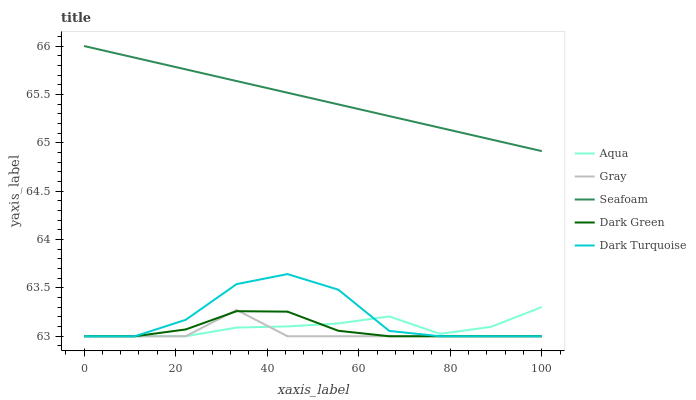Does Gray have the minimum area under the curve?
Answer yes or no. Yes. Does Seafoam have the maximum area under the curve?
Answer yes or no. Yes. Does Aqua have the minimum area under the curve?
Answer yes or no. No. Does Aqua have the maximum area under the curve?
Answer yes or no. No. Is Seafoam the smoothest?
Answer yes or no. Yes. Is Dark Turquoise the roughest?
Answer yes or no. Yes. Is Aqua the smoothest?
Answer yes or no. No. Is Aqua the roughest?
Answer yes or no. No. Does Seafoam have the lowest value?
Answer yes or no. No. Does Seafoam have the highest value?
Answer yes or no. Yes. Does Aqua have the highest value?
Answer yes or no. No. Is Aqua less than Seafoam?
Answer yes or no. Yes. Is Seafoam greater than Dark Green?
Answer yes or no. Yes. Does Dark Turquoise intersect Aqua?
Answer yes or no. Yes. Is Dark Turquoise less than Aqua?
Answer yes or no. No. Is Dark Turquoise greater than Aqua?
Answer yes or no. No. Does Aqua intersect Seafoam?
Answer yes or no. No. 